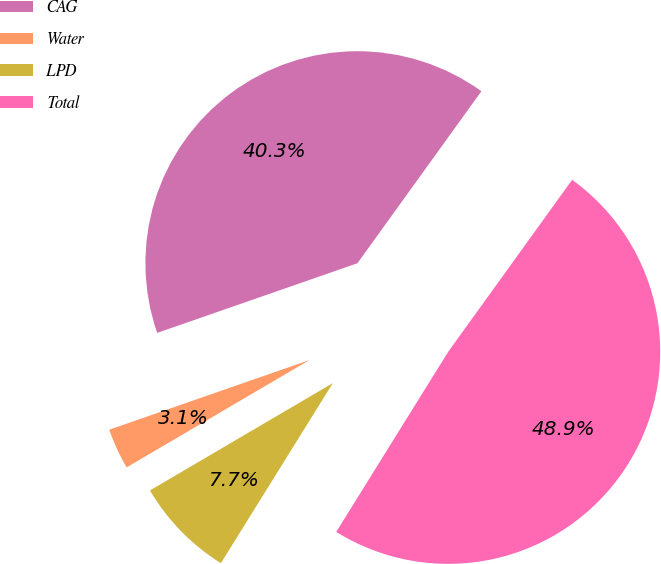<chart> <loc_0><loc_0><loc_500><loc_500><pie_chart><fcel>CAG<fcel>Water<fcel>LPD<fcel>Total<nl><fcel>40.27%<fcel>3.12%<fcel>7.7%<fcel>48.92%<nl></chart> 